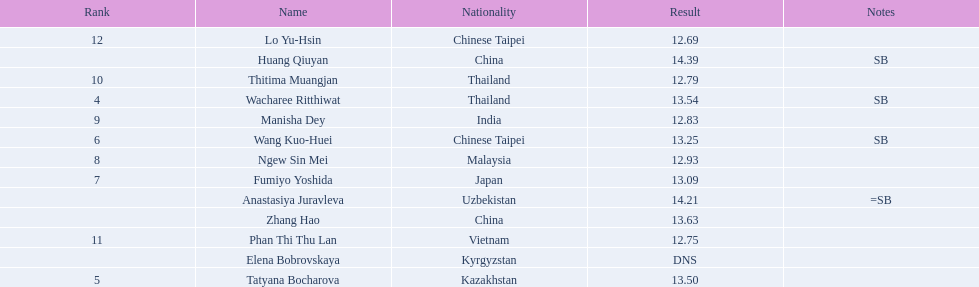How many contestants were from thailand? 2. 